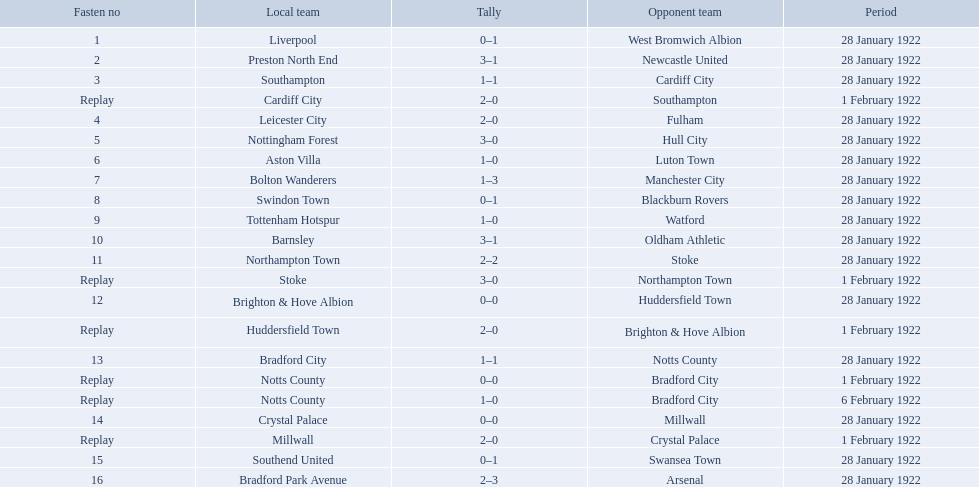Which team had a score of 0-1? Liverpool. Which team had a replay? Cardiff City. Which team had the same score as aston villa? Tottenham Hotspur. What was the score in the aston villa game? 1–0. Which other team had an identical score? Tottenham Hotspur. 